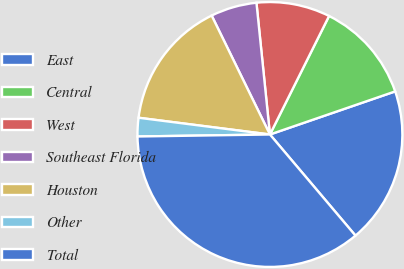Convert chart. <chart><loc_0><loc_0><loc_500><loc_500><pie_chart><fcel>East<fcel>Central<fcel>West<fcel>Southeast Florida<fcel>Houston<fcel>Other<fcel>Total<nl><fcel>19.1%<fcel>12.36%<fcel>8.99%<fcel>5.63%<fcel>15.73%<fcel>2.26%<fcel>35.94%<nl></chart> 